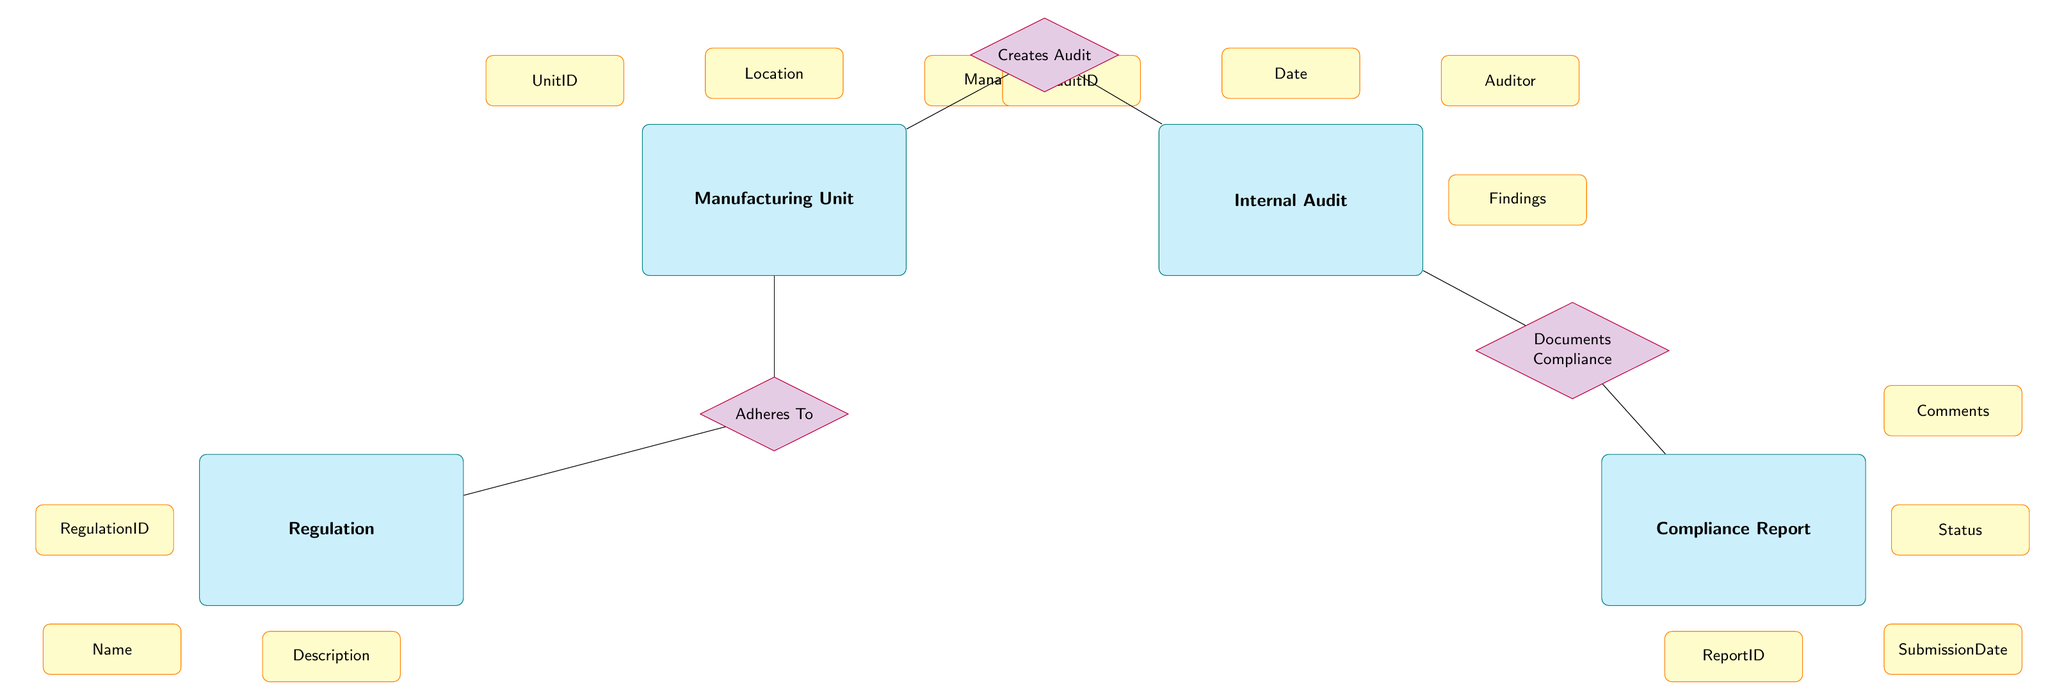What is the ID of the Internal Audit entity? The Internal Audit entity has an attribute called AuditID. According to the visual information in the diagram, this attribute is clearly labeled under the Internal Audit entity structure.
Answer: AuditID How many attributes does the Manufacturing Unit entity have? The Manufacturing Unit entity lists three attributes in the diagram: UnitID, Location, and Manager. Counting these attributes gives a total of three.
Answer: 3 What relationship connects the Manufacturing Unit and the Internal Audit? The connection between Manufacturing Unit and Internal Audit is established through the relationship labeled "Creates Audit." This is represented in the diagram as a directed edge from Manufacturing Unit to Internal Audit.
Answer: Creates Audit Which entity is responsible for documenting compliance? The entity that handles documentation of compliance is the Internal Audit, which has a relationship named "Documents Compliance" leading to the Compliance Report in the diagram. This means Internal Audit is instrumental in this process.
Answer: Internal Audit How many relationships are depicted in this diagram? The diagram illustrates three distinct relationships: "Creates Audit," "Documents Compliance," and "Adheres To." By counting these relationships, we determine the total number of connections present.
Answer: 3 What does the Compliance Report entity reference? The Compliance Report entity has four attributes: ReportID, SubmissionDate, Status, and Comments. These attributes define important aspects of the Compliance Report entity.
Answer: ReportID, SubmissionDate, Status, Comments Which regulation is associated with the Manufacturing Unit? The relationship labeled "Adheres To" connects the Manufacturing Unit entity to the Regulation entity. This indicates that there exists regulations which the Manufacturing Unit is required to adhere to, as visually represented in the diagram.
Answer: Regulation What is the primary purpose of the Internal Audit? Based on the diagram, the Internal Audit primarily serves the purpose of documenting compliance, as shown in the relationship "Documents Compliance" with the Compliance Report. This reflects the role of Internal Audit in ensuring regulation adherence.
Answer: Documenting compliance What is the connection between Compliance Report and Internal Audit? The Compliance Report is connected to the Internal Audit through the relationship "Documents Compliance." This indicates that the Internal Audit plays an essential role in the preparation or creation of Compliance Report documents.
Answer: Documents Compliance 